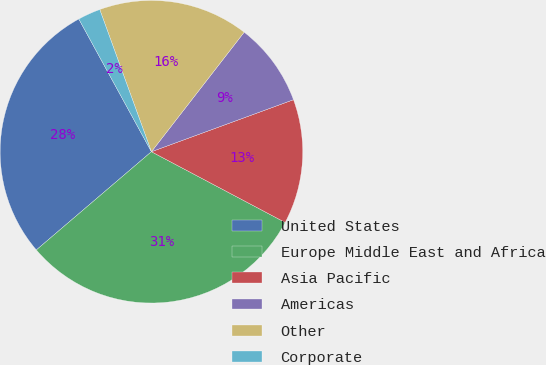Convert chart to OTSL. <chart><loc_0><loc_0><loc_500><loc_500><pie_chart><fcel>United States<fcel>Europe Middle East and Africa<fcel>Asia Pacific<fcel>Americas<fcel>Other<fcel>Corporate<nl><fcel>28.28%<fcel>31.01%<fcel>13.33%<fcel>8.91%<fcel>16.05%<fcel>2.42%<nl></chart> 